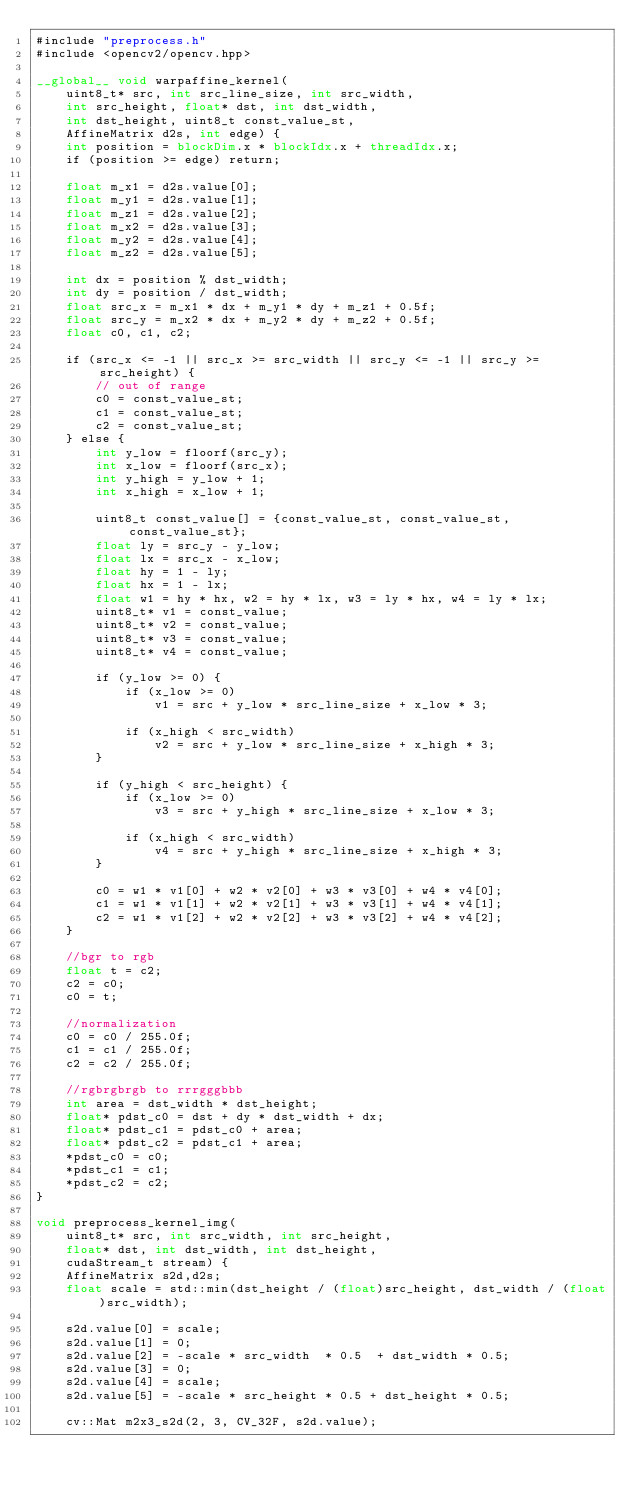Convert code to text. <code><loc_0><loc_0><loc_500><loc_500><_Cuda_>#include "preprocess.h"
#include <opencv2/opencv.hpp>

__global__ void warpaffine_kernel( 
    uint8_t* src, int src_line_size, int src_width, 
    int src_height, float* dst, int dst_width, 
    int dst_height, uint8_t const_value_st,
    AffineMatrix d2s, int edge) {
    int position = blockDim.x * blockIdx.x + threadIdx.x;
    if (position >= edge) return;

    float m_x1 = d2s.value[0];
    float m_y1 = d2s.value[1];
    float m_z1 = d2s.value[2];
    float m_x2 = d2s.value[3];
    float m_y2 = d2s.value[4];
    float m_z2 = d2s.value[5];

    int dx = position % dst_width;
    int dy = position / dst_width;
    float src_x = m_x1 * dx + m_y1 * dy + m_z1 + 0.5f;
    float src_y = m_x2 * dx + m_y2 * dy + m_z2 + 0.5f;
    float c0, c1, c2;

    if (src_x <= -1 || src_x >= src_width || src_y <= -1 || src_y >= src_height) {
        // out of range
        c0 = const_value_st;
        c1 = const_value_st;
        c2 = const_value_st;
    } else {
        int y_low = floorf(src_y);
        int x_low = floorf(src_x);
        int y_high = y_low + 1;
        int x_high = x_low + 1;

        uint8_t const_value[] = {const_value_st, const_value_st, const_value_st};
        float ly = src_y - y_low;
        float lx = src_x - x_low;
        float hy = 1 - ly;
        float hx = 1 - lx;
        float w1 = hy * hx, w2 = hy * lx, w3 = ly * hx, w4 = ly * lx;
        uint8_t* v1 = const_value;
        uint8_t* v2 = const_value;
        uint8_t* v3 = const_value;
        uint8_t* v4 = const_value;

        if (y_low >= 0) {
            if (x_low >= 0)
                v1 = src + y_low * src_line_size + x_low * 3;

            if (x_high < src_width)
                v2 = src + y_low * src_line_size + x_high * 3;
        }

        if (y_high < src_height) {
            if (x_low >= 0)
                v3 = src + y_high * src_line_size + x_low * 3;

            if (x_high < src_width)
                v4 = src + y_high * src_line_size + x_high * 3;
        }

        c0 = w1 * v1[0] + w2 * v2[0] + w3 * v3[0] + w4 * v4[0];
        c1 = w1 * v1[1] + w2 * v2[1] + w3 * v3[1] + w4 * v4[1];
        c2 = w1 * v1[2] + w2 * v2[2] + w3 * v3[2] + w4 * v4[2];
    }

    //bgr to rgb 
    float t = c2;
    c2 = c0;
    c0 = t;

    //normalization
    c0 = c0 / 255.0f;
    c1 = c1 / 255.0f;
    c2 = c2 / 255.0f;

    //rgbrgbrgb to rrrgggbbb
    int area = dst_width * dst_height;
    float* pdst_c0 = dst + dy * dst_width + dx;
    float* pdst_c1 = pdst_c0 + area;
    float* pdst_c2 = pdst_c1 + area;
    *pdst_c0 = c0;
    *pdst_c1 = c1;
    *pdst_c2 = c2;
}

void preprocess_kernel_img(
    uint8_t* src, int src_width, int src_height,
    float* dst, int dst_width, int dst_height,
    cudaStream_t stream) {
    AffineMatrix s2d,d2s;
    float scale = std::min(dst_height / (float)src_height, dst_width / (float)src_width);

    s2d.value[0] = scale;
    s2d.value[1] = 0;
    s2d.value[2] = -scale * src_width  * 0.5  + dst_width * 0.5;
    s2d.value[3] = 0;
    s2d.value[4] = scale;
    s2d.value[5] = -scale * src_height * 0.5 + dst_height * 0.5;

    cv::Mat m2x3_s2d(2, 3, CV_32F, s2d.value);</code> 